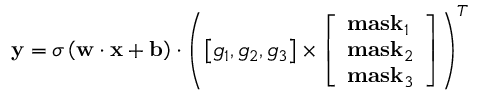Convert formula to latex. <formula><loc_0><loc_0><loc_500><loc_500>{ y } = \sigma \left ( { { w } \cdot { x } + { b } } \right ) \cdot { \left ( { \left [ { { g _ { 1 } } , { g _ { 2 } } , { g _ { 3 } } } \right ] \times \left [ \begin{array} { l } { { m a s } { { k } _ { 1 } } } \\ { { m a s } { { k } _ { 2 } } } \\ { { m a s } { { k } _ { 3 } } } \end{array} \right ] } \right ) ^ { T } }</formula> 